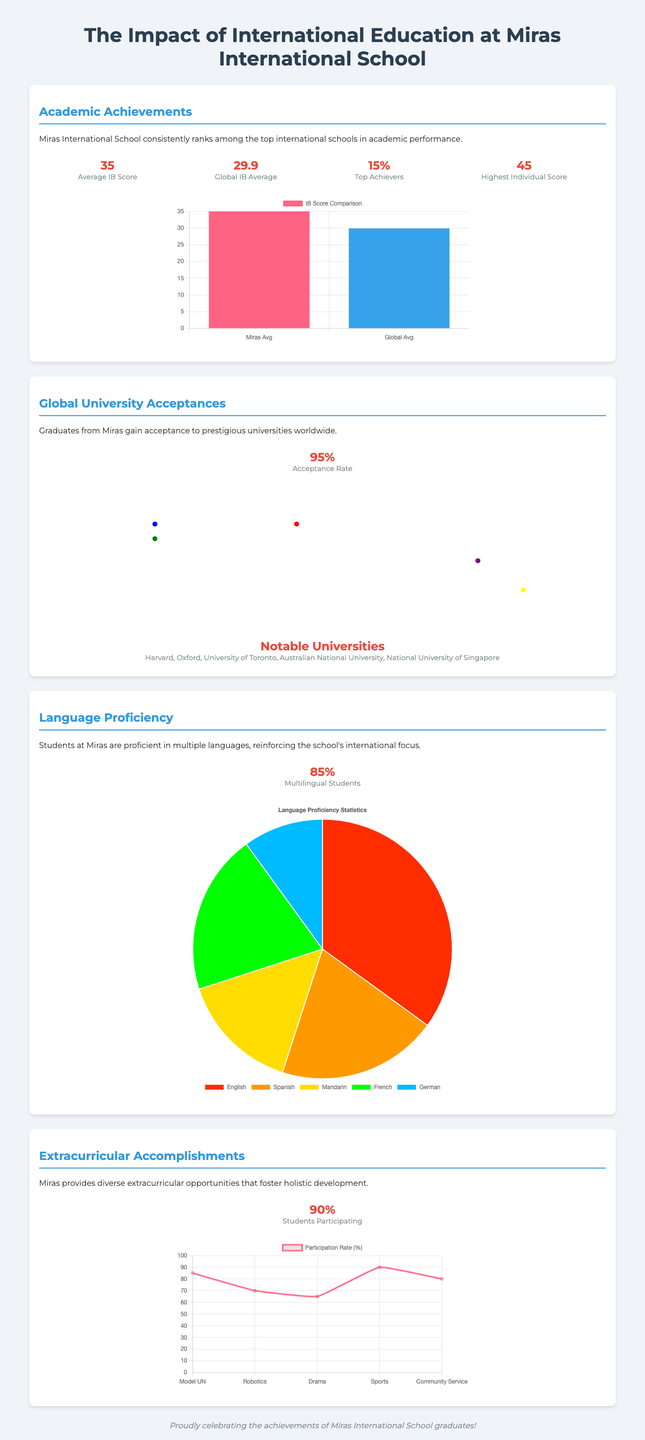What is the average IB score at Miras? The average IB score at Miras is highlighted in the statistics section and is stated as 35.
Answer: 35 What is the global IB average score? The document provides the global IB average score, which is 29.9.
Answer: 29.9 What percentage of Miras students are multilingual? The document states that 85% of students are multilingual, which is a statistic included in the section on language proficiency.
Answer: 85% Which prestigious university does Miras graduates get accepted to? The document mentions several notable universities, including Harvard, which is listed in the global university acceptance section.
Answer: Harvard What percentage of students participate in extracurricular activities? According to the infographic, 90% of students participate in extracurricular activities.
Answer: 90% How many top achievers are there at Miras? The statistic indicating the percentage of top achievers at Miras is 15%.
Answer: 15% What type of chart is used to display IB Score Comparison? The document clearly specifies that a bar chart illustrates the IB Score Comparison.
Answer: Bar What are the names of two extracurricular activities listed? The document provides a list of extracurricular activities, including Model UN and Robotics specifically mentioned in the chart section.
Answer: Model UN, Robotics What is the acceptance rate for Miras graduates? The acceptance rate for Miras graduates to universities worldwide is stated as 95%.
Answer: 95% 